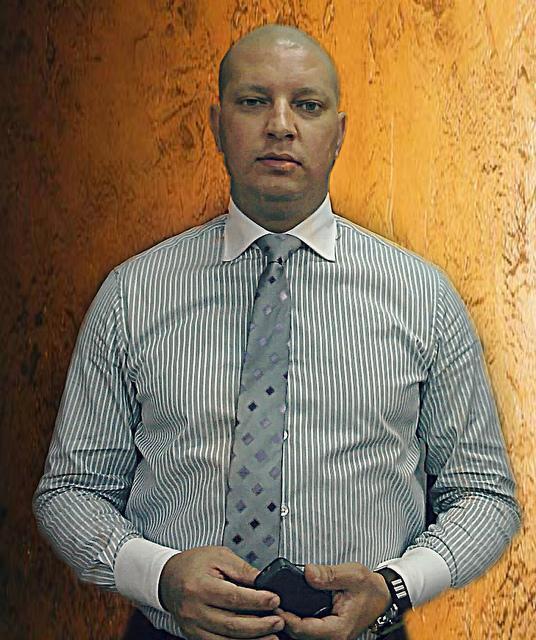How many people are wearing an orange shirt?
Give a very brief answer. 0. 